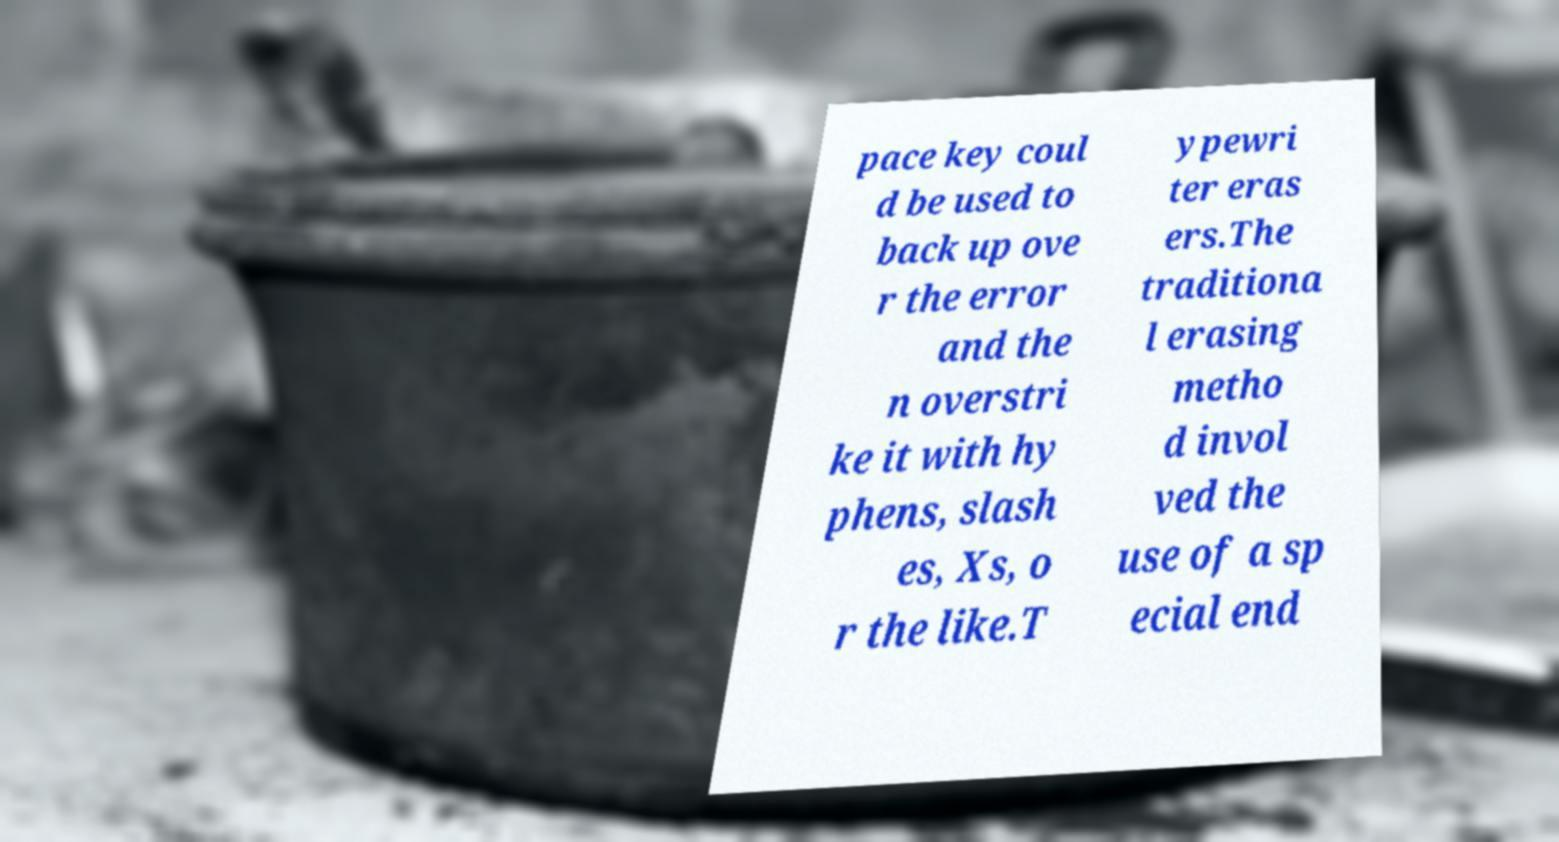Can you read and provide the text displayed in the image?This photo seems to have some interesting text. Can you extract and type it out for me? pace key coul d be used to back up ove r the error and the n overstri ke it with hy phens, slash es, Xs, o r the like.T ypewri ter eras ers.The traditiona l erasing metho d invol ved the use of a sp ecial end 